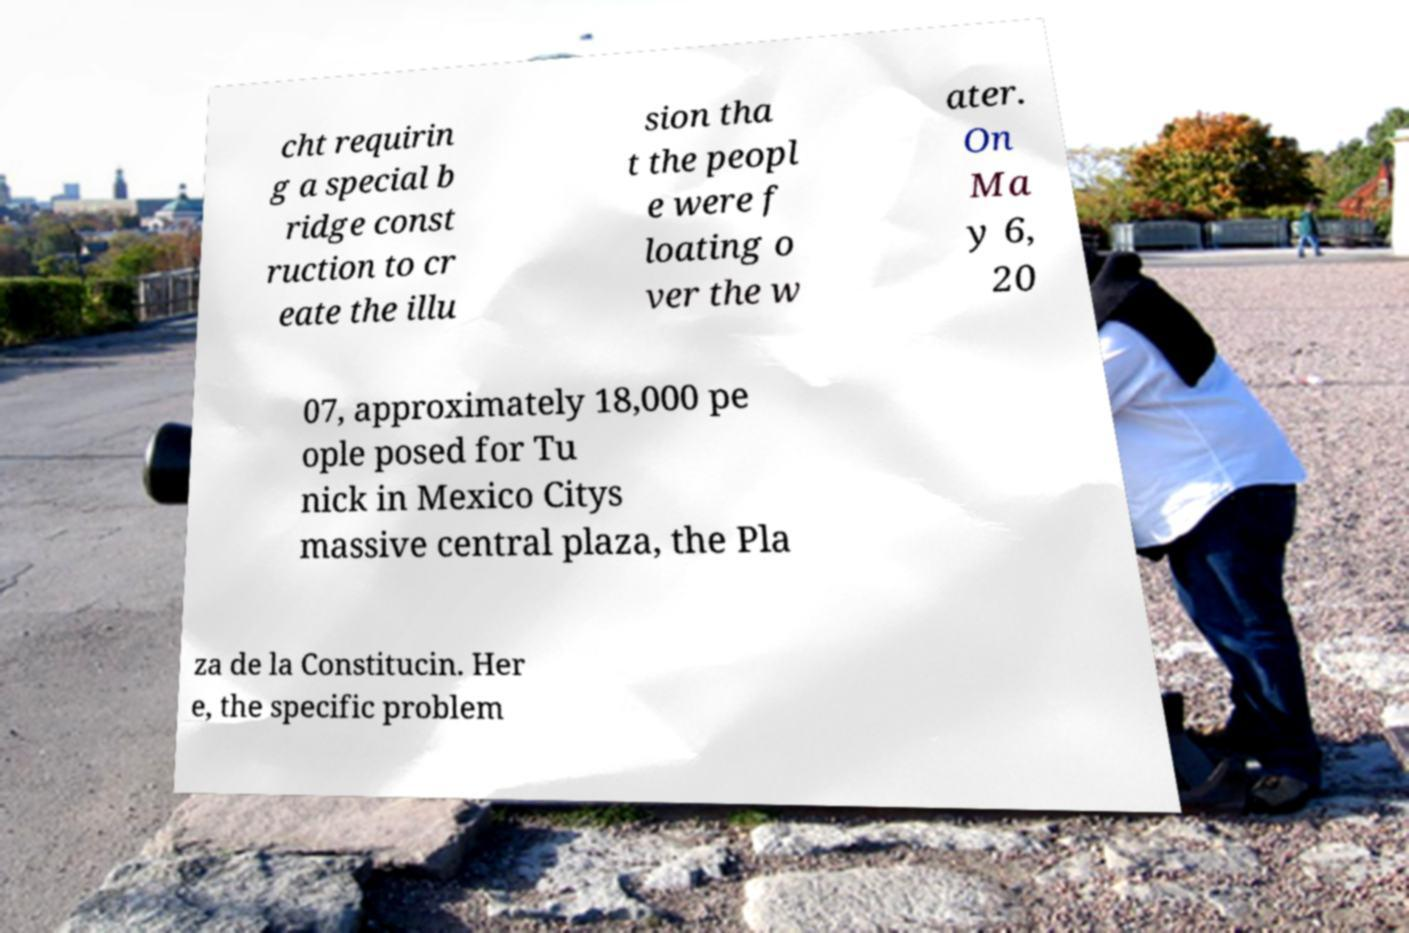Could you assist in decoding the text presented in this image and type it out clearly? cht requirin g a special b ridge const ruction to cr eate the illu sion tha t the peopl e were f loating o ver the w ater. On Ma y 6, 20 07, approximately 18,000 pe ople posed for Tu nick in Mexico Citys massive central plaza, the Pla za de la Constitucin. Her e, the specific problem 